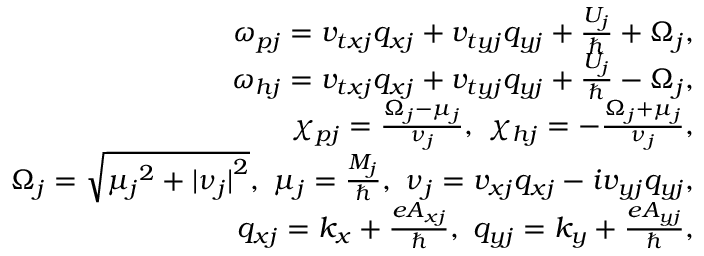Convert formula to latex. <formula><loc_0><loc_0><loc_500><loc_500>\begin{array} { r l r } & { \omega _ { p j } = v _ { t x j } q _ { x j } + v _ { t y j } q _ { y j } + \frac { U _ { j } } { } + \Omega _ { j } , } \\ & { \omega _ { h j } = v _ { t x j } q _ { x j } + v _ { t y j } q _ { y j } + \frac { U _ { j } } { } - \Omega _ { j } , } \\ & { \chi _ { p j } = \frac { \Omega _ { j } - \mu _ { j } } { \nu _ { j } } , \chi _ { h j } = - \frac { \Omega _ { j } + \mu _ { j } } { \nu _ { j } } , } \\ & { \Omega _ { j } = \sqrt { { \mu _ { j } } ^ { 2 } + { | \nu _ { j } | } ^ { 2 } } , \mu _ { j } = \frac { M _ { j } } { } , \nu _ { j } = v _ { x j } q _ { x j } - i v _ { y j } q _ { y j } , } \\ & { q _ { x j } = k _ { x } + \frac { e A _ { x j } } { } , q _ { y j } = k _ { y } + \frac { e A _ { y j } } { } , } \end{array}</formula> 